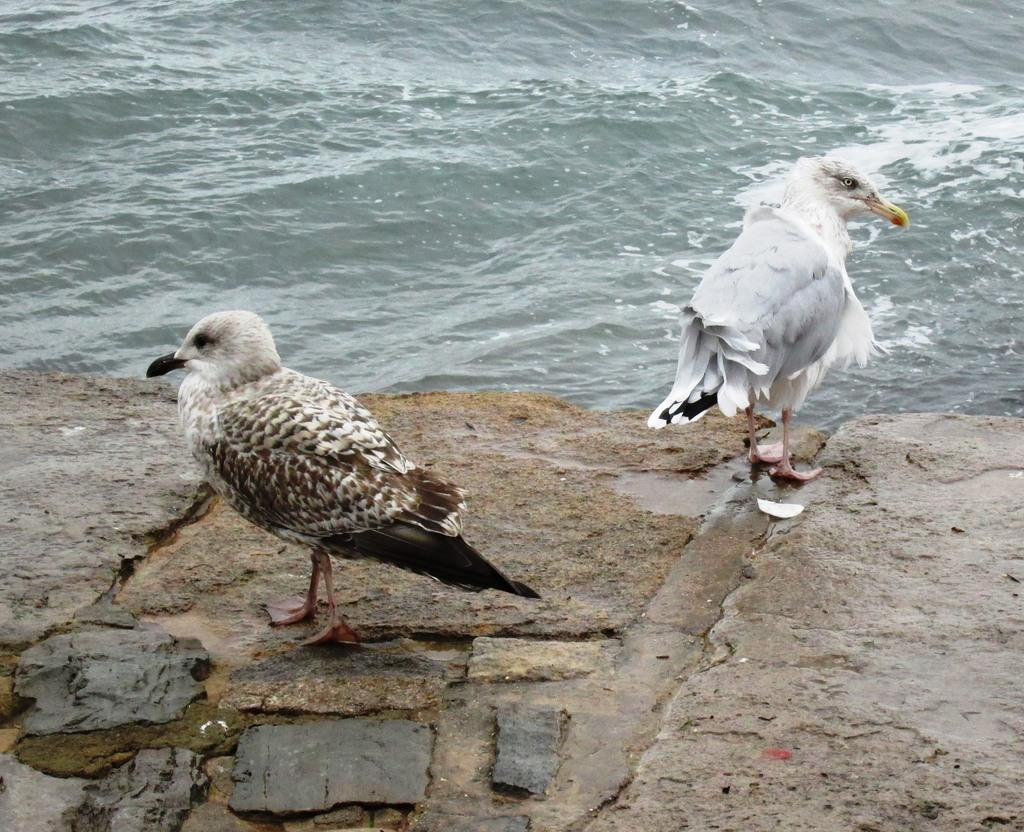What type of animals can be seen on the ground in the image? There are birds on the ground in the image. What is visible in the image besides the birds? There is water visible in the image. How many legs does the window have in the image? There is no window present in the image, so it is not possible to determine how many legs it might have. 